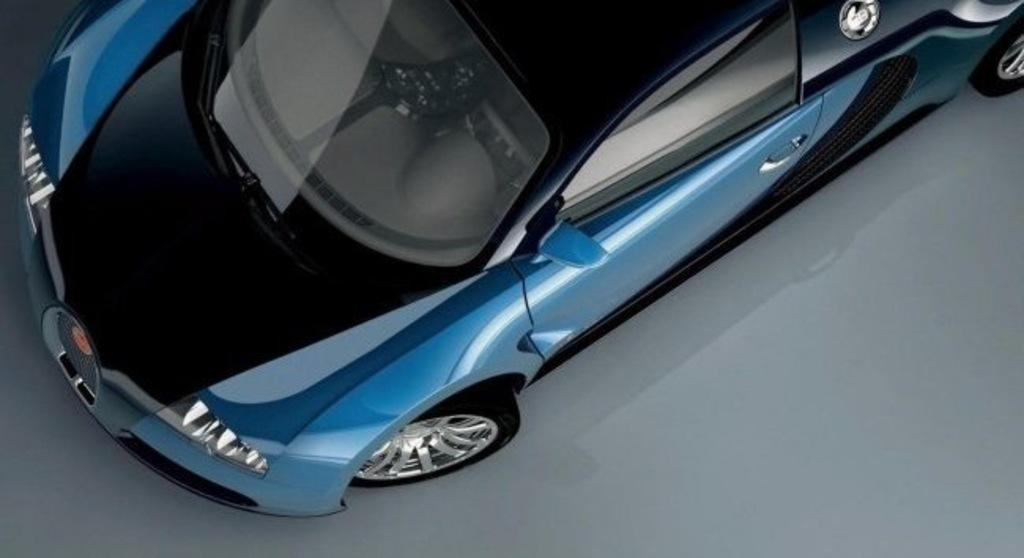What is the main subject of the image? The main subject of the image is a car. Where is the car located in the image? The car is parked on the ground in the image. What type of wool is being used to make the car's tires in the image? There is no wool present in the image, and the car's tires are made of rubber, not wool. How much profit is the car owner making from the car in the image? There is no information about the car owner or any profit in the image, so it cannot be determined. 